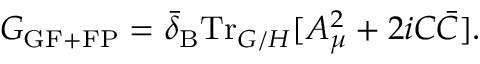<formula> <loc_0><loc_0><loc_500><loc_500>G _ { G F + F P } = \bar { \delta } _ { B } T r _ { G / H } [ A _ { \mu } ^ { 2 } + 2 i C \bar { C } ] .</formula> 